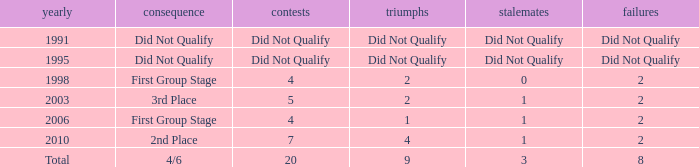What were the matches where the teams finished in the first group stage, in 1998? 4.0. 